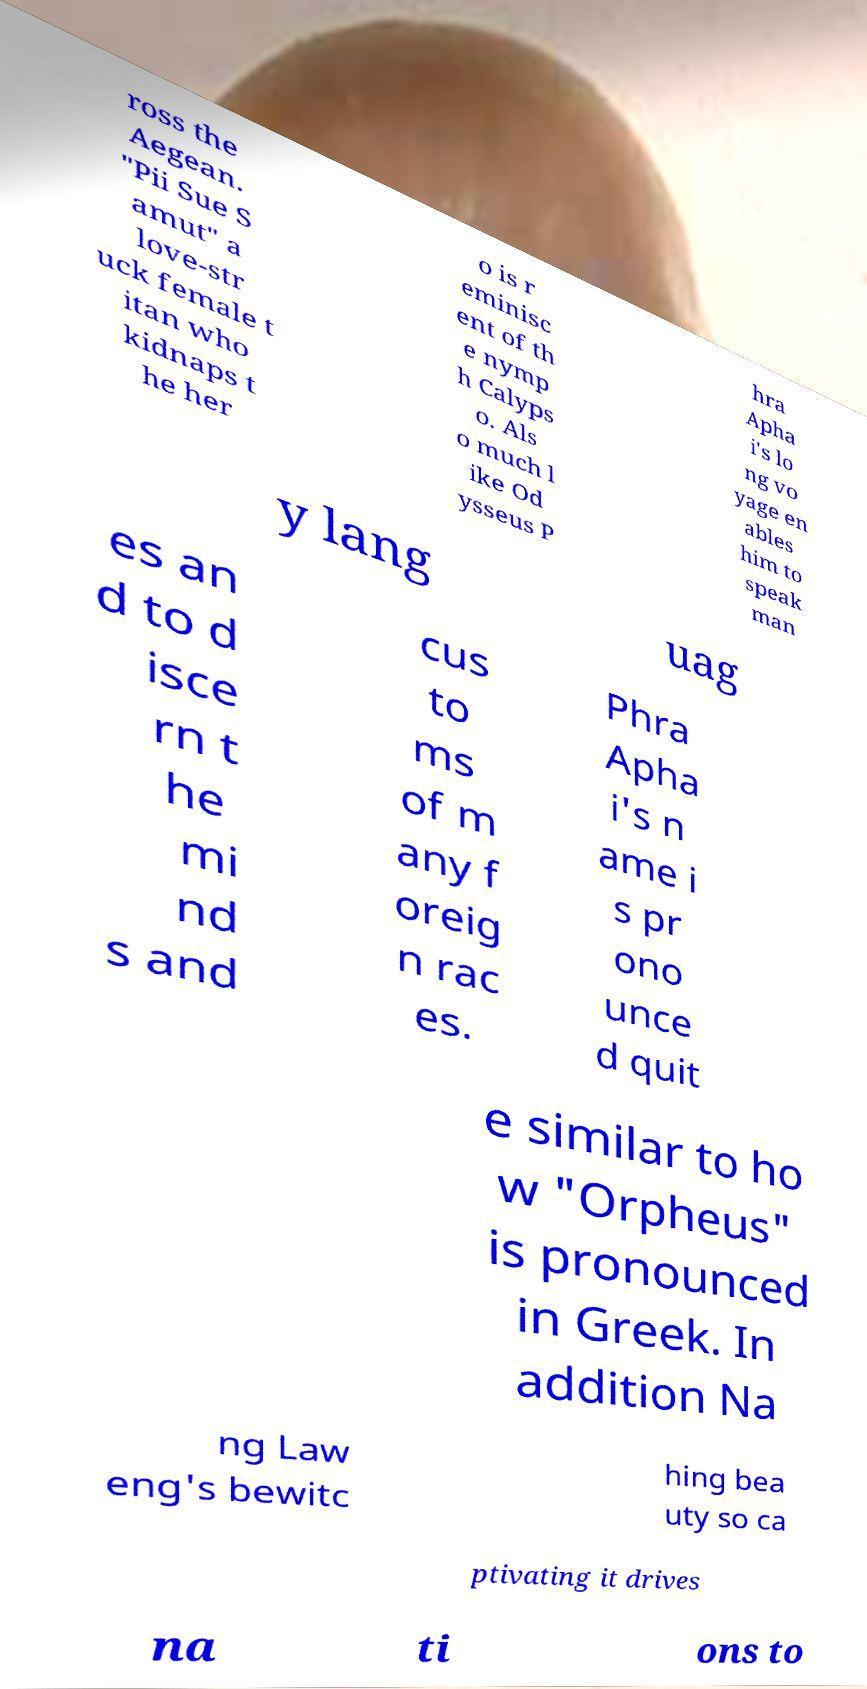Could you extract and type out the text from this image? ross the Aegean. "Pii Sue S amut" a love-str uck female t itan who kidnaps t he her o is r eminisc ent of th e nymp h Calyps o. Als o much l ike Od ysseus P hra Apha i's lo ng vo yage en ables him to speak man y lang uag es an d to d isce rn t he mi nd s and cus to ms of m any f oreig n rac es. Phra Apha i's n ame i s pr ono unce d quit e similar to ho w "Orpheus" is pronounced in Greek. In addition Na ng Law eng's bewitc hing bea uty so ca ptivating it drives na ti ons to 